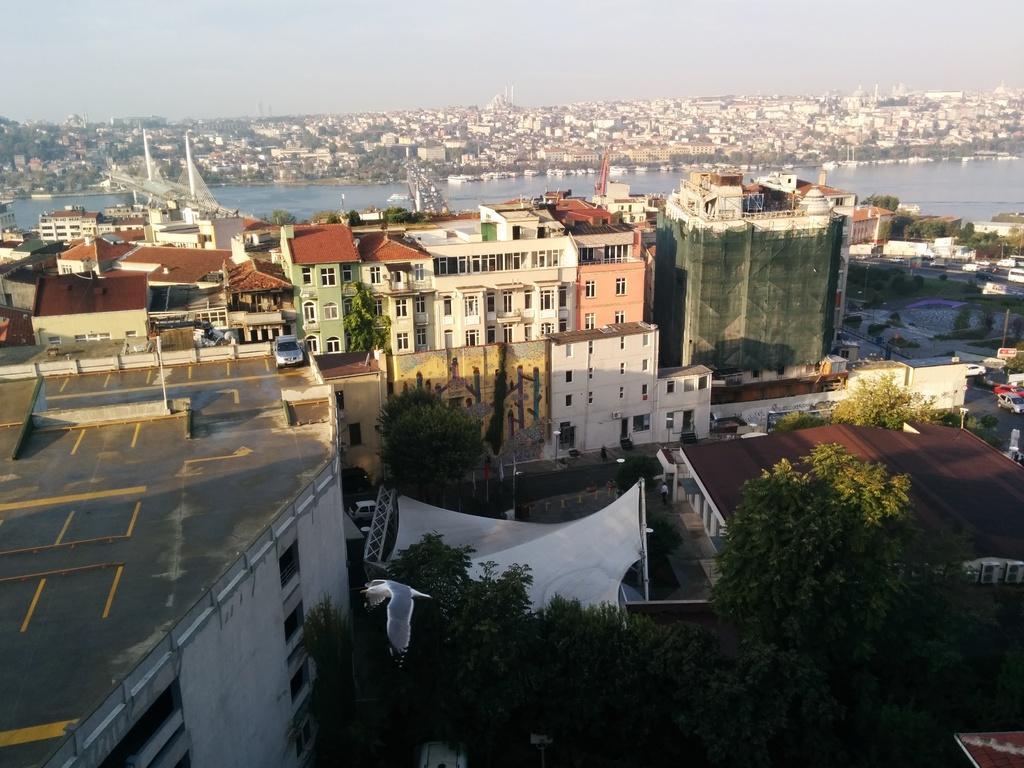Describe this image in one or two sentences. In this picture I can see buildings, trees, vehicles, poles, those are looking like bridges, there is water, and in the background there is sky. 